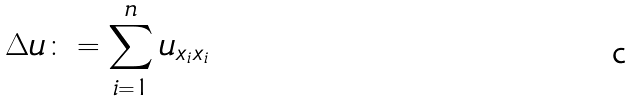Convert formula to latex. <formula><loc_0><loc_0><loc_500><loc_500>\Delta u \colon = \sum _ { i = 1 } ^ { n } u _ { x _ { i } x _ { i } }</formula> 